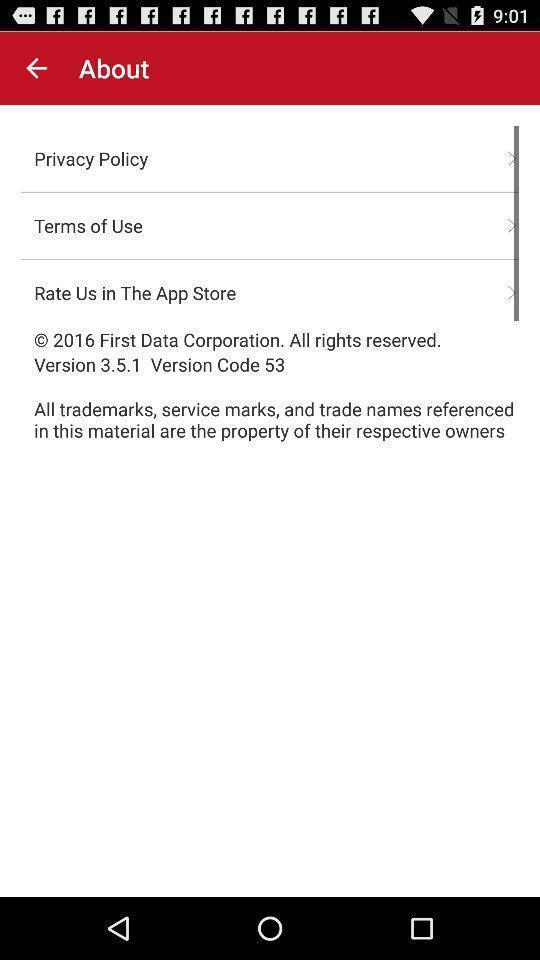Describe this image in words. Screen shows about page. 